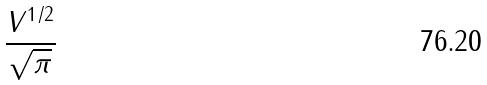Convert formula to latex. <formula><loc_0><loc_0><loc_500><loc_500>\frac { V ^ { 1 / 2 } } { \sqrt { \pi } }</formula> 